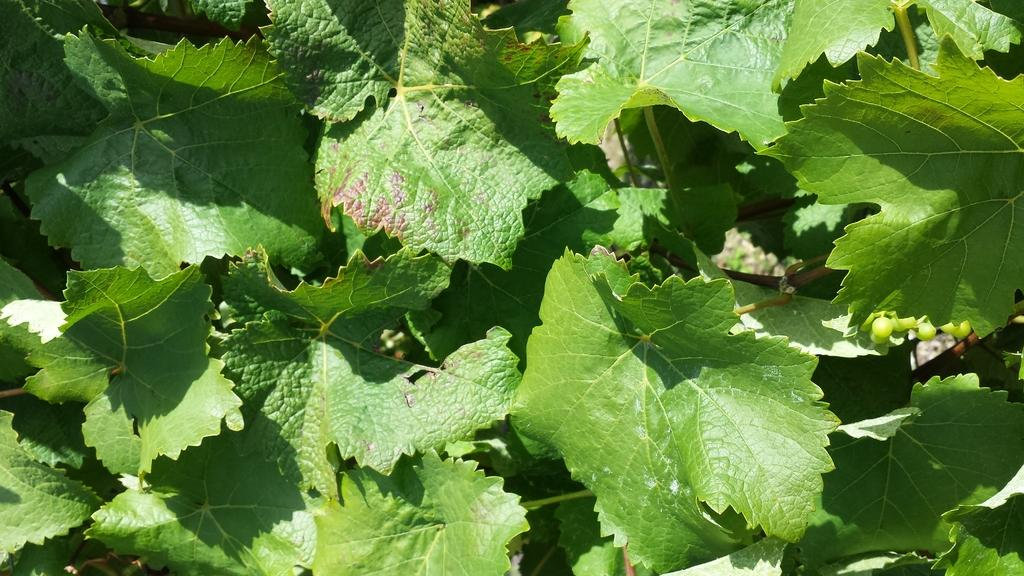What type of vegetation can be seen in the image? There are leaves in the image. What part of a quince tree can be seen in the image? There is no quince tree or any part of it present in the image; only leaves are visible. 